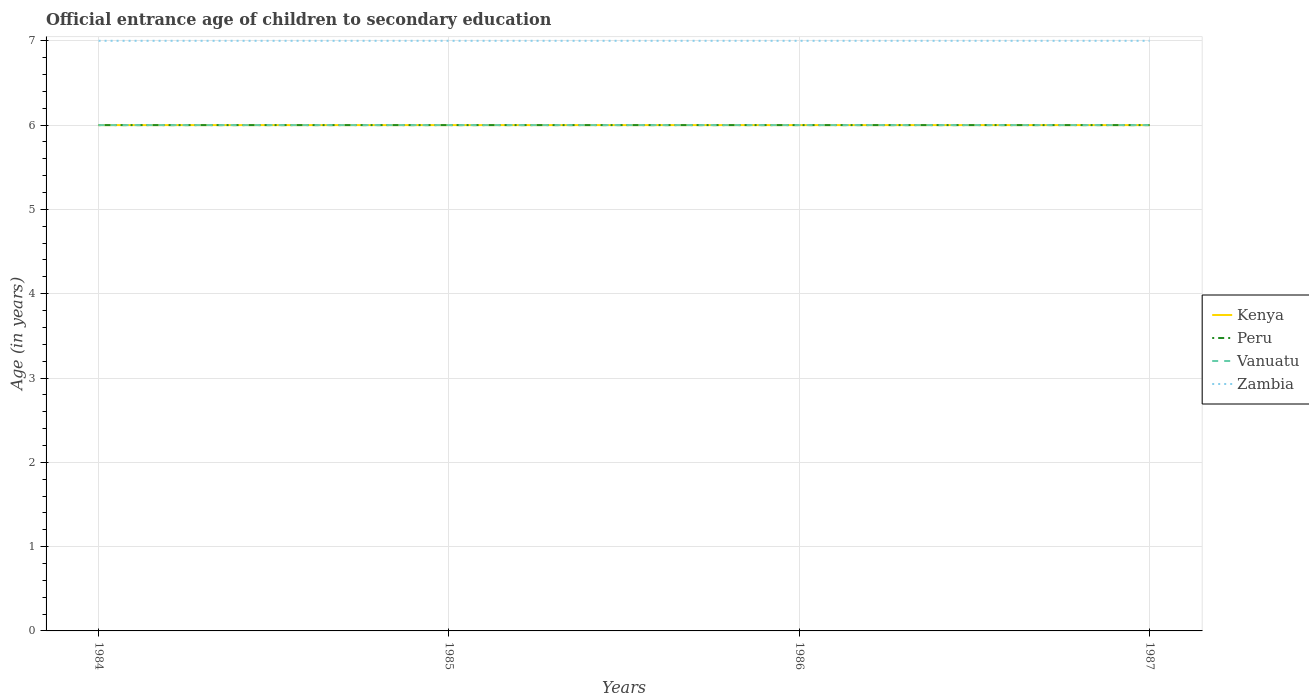Across all years, what is the maximum secondary school starting age of children in Peru?
Give a very brief answer. 6. What is the total secondary school starting age of children in Kenya in the graph?
Your response must be concise. 0. How many years are there in the graph?
Offer a very short reply. 4. What is the difference between two consecutive major ticks on the Y-axis?
Provide a succinct answer. 1. Are the values on the major ticks of Y-axis written in scientific E-notation?
Provide a short and direct response. No. Does the graph contain grids?
Offer a terse response. Yes. Where does the legend appear in the graph?
Offer a terse response. Center right. How many legend labels are there?
Keep it short and to the point. 4. How are the legend labels stacked?
Make the answer very short. Vertical. What is the title of the graph?
Your answer should be very brief. Official entrance age of children to secondary education. What is the label or title of the Y-axis?
Offer a very short reply. Age (in years). What is the Age (in years) in Kenya in 1984?
Make the answer very short. 6. What is the Age (in years) in Zambia in 1984?
Your response must be concise. 7. What is the Age (in years) of Kenya in 1985?
Keep it short and to the point. 6. What is the Age (in years) in Vanuatu in 1985?
Your response must be concise. 6. What is the Age (in years) in Vanuatu in 1986?
Your answer should be very brief. 6. What is the Age (in years) of Peru in 1987?
Offer a terse response. 6. What is the Age (in years) of Vanuatu in 1987?
Provide a succinct answer. 6. What is the Age (in years) of Zambia in 1987?
Make the answer very short. 7. Across all years, what is the maximum Age (in years) of Zambia?
Your answer should be compact. 7. Across all years, what is the minimum Age (in years) in Kenya?
Your response must be concise. 6. Across all years, what is the minimum Age (in years) in Peru?
Make the answer very short. 6. Across all years, what is the minimum Age (in years) in Zambia?
Your answer should be very brief. 7. What is the total Age (in years) of Zambia in the graph?
Make the answer very short. 28. What is the difference between the Age (in years) of Kenya in 1984 and that in 1985?
Provide a short and direct response. 0. What is the difference between the Age (in years) in Peru in 1984 and that in 1985?
Offer a very short reply. 0. What is the difference between the Age (in years) of Kenya in 1984 and that in 1986?
Offer a very short reply. 0. What is the difference between the Age (in years) of Vanuatu in 1984 and that in 1986?
Keep it short and to the point. 0. What is the difference between the Age (in years) of Zambia in 1984 and that in 1986?
Keep it short and to the point. 0. What is the difference between the Age (in years) of Kenya in 1984 and that in 1987?
Offer a terse response. 0. What is the difference between the Age (in years) of Vanuatu in 1984 and that in 1987?
Offer a very short reply. 0. What is the difference between the Age (in years) in Zambia in 1984 and that in 1987?
Your answer should be very brief. 0. What is the difference between the Age (in years) in Kenya in 1985 and that in 1986?
Your response must be concise. 0. What is the difference between the Age (in years) in Peru in 1985 and that in 1986?
Your response must be concise. 0. What is the difference between the Age (in years) in Kenya in 1985 and that in 1987?
Ensure brevity in your answer.  0. What is the difference between the Age (in years) in Peru in 1985 and that in 1987?
Keep it short and to the point. 0. What is the difference between the Age (in years) in Vanuatu in 1985 and that in 1987?
Provide a short and direct response. 0. What is the difference between the Age (in years) in Zambia in 1985 and that in 1987?
Provide a short and direct response. 0. What is the difference between the Age (in years) in Kenya in 1984 and the Age (in years) in Zambia in 1985?
Offer a very short reply. -1. What is the difference between the Age (in years) of Peru in 1984 and the Age (in years) of Vanuatu in 1985?
Ensure brevity in your answer.  0. What is the difference between the Age (in years) of Kenya in 1984 and the Age (in years) of Vanuatu in 1986?
Your answer should be very brief. 0. What is the difference between the Age (in years) of Peru in 1984 and the Age (in years) of Vanuatu in 1986?
Your answer should be very brief. 0. What is the difference between the Age (in years) in Peru in 1984 and the Age (in years) in Zambia in 1986?
Make the answer very short. -1. What is the difference between the Age (in years) in Kenya in 1984 and the Age (in years) in Peru in 1987?
Keep it short and to the point. 0. What is the difference between the Age (in years) of Kenya in 1984 and the Age (in years) of Vanuatu in 1987?
Provide a short and direct response. 0. What is the difference between the Age (in years) of Peru in 1984 and the Age (in years) of Zambia in 1987?
Give a very brief answer. -1. What is the difference between the Age (in years) in Vanuatu in 1984 and the Age (in years) in Zambia in 1987?
Provide a short and direct response. -1. What is the difference between the Age (in years) of Vanuatu in 1985 and the Age (in years) of Zambia in 1986?
Offer a very short reply. -1. What is the difference between the Age (in years) in Kenya in 1985 and the Age (in years) in Peru in 1987?
Your answer should be compact. 0. What is the difference between the Age (in years) in Peru in 1985 and the Age (in years) in Vanuatu in 1987?
Provide a short and direct response. 0. What is the difference between the Age (in years) of Vanuatu in 1985 and the Age (in years) of Zambia in 1987?
Offer a terse response. -1. What is the difference between the Age (in years) of Kenya in 1986 and the Age (in years) of Peru in 1987?
Your response must be concise. 0. What is the difference between the Age (in years) of Kenya in 1986 and the Age (in years) of Zambia in 1987?
Provide a succinct answer. -1. What is the difference between the Age (in years) of Peru in 1986 and the Age (in years) of Zambia in 1987?
Your response must be concise. -1. What is the difference between the Age (in years) of Vanuatu in 1986 and the Age (in years) of Zambia in 1987?
Make the answer very short. -1. What is the average Age (in years) of Kenya per year?
Your response must be concise. 6. In the year 1984, what is the difference between the Age (in years) in Kenya and Age (in years) in Vanuatu?
Provide a short and direct response. 0. In the year 1984, what is the difference between the Age (in years) of Kenya and Age (in years) of Zambia?
Keep it short and to the point. -1. In the year 1984, what is the difference between the Age (in years) in Peru and Age (in years) in Vanuatu?
Ensure brevity in your answer.  0. In the year 1984, what is the difference between the Age (in years) in Vanuatu and Age (in years) in Zambia?
Offer a terse response. -1. In the year 1985, what is the difference between the Age (in years) of Kenya and Age (in years) of Peru?
Offer a terse response. 0. In the year 1985, what is the difference between the Age (in years) of Kenya and Age (in years) of Zambia?
Offer a terse response. -1. In the year 1985, what is the difference between the Age (in years) of Peru and Age (in years) of Zambia?
Provide a short and direct response. -1. In the year 1986, what is the difference between the Age (in years) of Kenya and Age (in years) of Peru?
Give a very brief answer. 0. In the year 1986, what is the difference between the Age (in years) of Peru and Age (in years) of Zambia?
Ensure brevity in your answer.  -1. In the year 1986, what is the difference between the Age (in years) in Vanuatu and Age (in years) in Zambia?
Keep it short and to the point. -1. In the year 1987, what is the difference between the Age (in years) in Kenya and Age (in years) in Vanuatu?
Provide a short and direct response. 0. In the year 1987, what is the difference between the Age (in years) of Peru and Age (in years) of Vanuatu?
Ensure brevity in your answer.  0. In the year 1987, what is the difference between the Age (in years) of Vanuatu and Age (in years) of Zambia?
Give a very brief answer. -1. What is the ratio of the Age (in years) in Kenya in 1984 to that in 1985?
Offer a very short reply. 1. What is the ratio of the Age (in years) of Peru in 1984 to that in 1985?
Offer a very short reply. 1. What is the ratio of the Age (in years) of Vanuatu in 1984 to that in 1985?
Provide a short and direct response. 1. What is the ratio of the Age (in years) in Zambia in 1984 to that in 1985?
Your response must be concise. 1. What is the ratio of the Age (in years) of Zambia in 1984 to that in 1986?
Offer a very short reply. 1. What is the ratio of the Age (in years) of Peru in 1984 to that in 1987?
Give a very brief answer. 1. What is the ratio of the Age (in years) of Vanuatu in 1984 to that in 1987?
Your answer should be compact. 1. What is the ratio of the Age (in years) in Zambia in 1984 to that in 1987?
Your answer should be compact. 1. What is the ratio of the Age (in years) of Peru in 1985 to that in 1986?
Ensure brevity in your answer.  1. What is the ratio of the Age (in years) in Vanuatu in 1985 to that in 1986?
Give a very brief answer. 1. What is the ratio of the Age (in years) in Kenya in 1985 to that in 1987?
Ensure brevity in your answer.  1. What is the ratio of the Age (in years) of Peru in 1985 to that in 1987?
Offer a terse response. 1. What is the ratio of the Age (in years) of Vanuatu in 1985 to that in 1987?
Make the answer very short. 1. What is the ratio of the Age (in years) of Zambia in 1985 to that in 1987?
Provide a short and direct response. 1. What is the ratio of the Age (in years) in Peru in 1986 to that in 1987?
Keep it short and to the point. 1. What is the ratio of the Age (in years) of Vanuatu in 1986 to that in 1987?
Keep it short and to the point. 1. What is the difference between the highest and the second highest Age (in years) of Vanuatu?
Your answer should be compact. 0. What is the difference between the highest and the second highest Age (in years) in Zambia?
Provide a succinct answer. 0. What is the difference between the highest and the lowest Age (in years) in Vanuatu?
Keep it short and to the point. 0. What is the difference between the highest and the lowest Age (in years) in Zambia?
Make the answer very short. 0. 